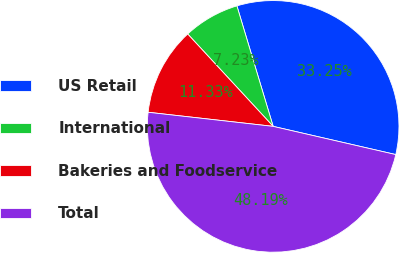Convert chart to OTSL. <chart><loc_0><loc_0><loc_500><loc_500><pie_chart><fcel>US Retail<fcel>International<fcel>Bakeries and Foodservice<fcel>Total<nl><fcel>33.25%<fcel>7.23%<fcel>11.33%<fcel>48.19%<nl></chart> 